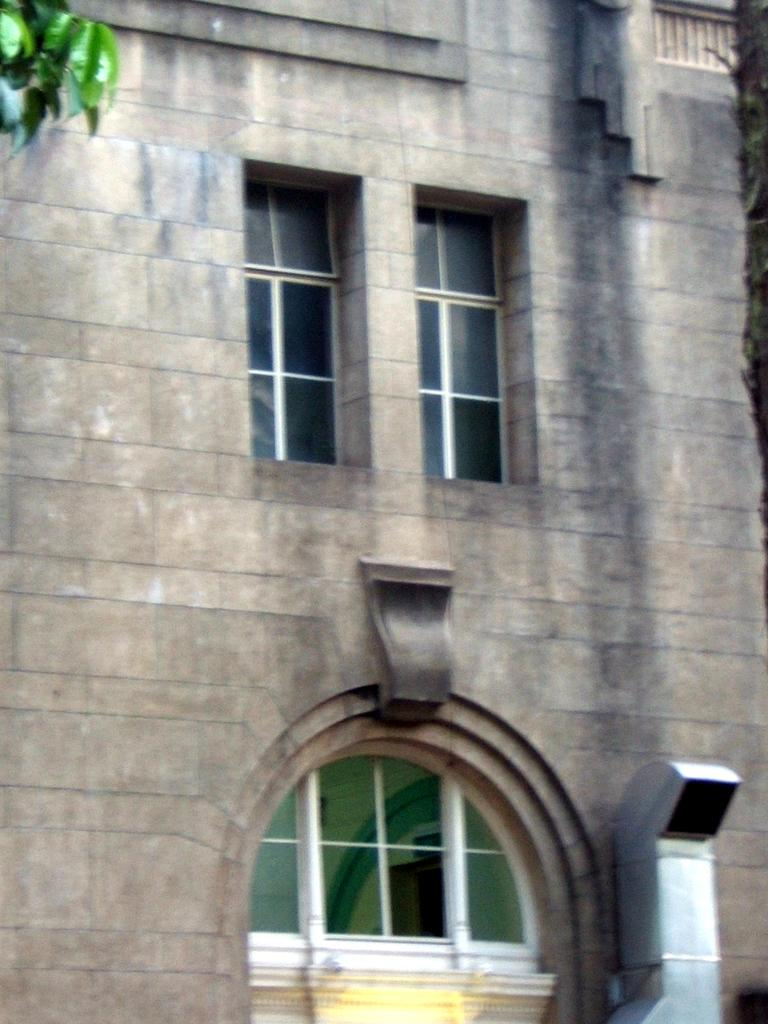What can be seen on the wall in the image? There are windows on the wall in the image. What is visible in the top right hand side of the image? There are leaves visible in the top right hand side of the image. What is located in the bottom right hand side of the image? There is a smoke exhaust pipe in the bottom right hand side of the image. What type of angle is being taught in the image? There is no teaching or angle present in the image; it features windows, leaves, and a smoke exhaust pipe. Can you see an airplane in the image? There is no airplane present in the image. 